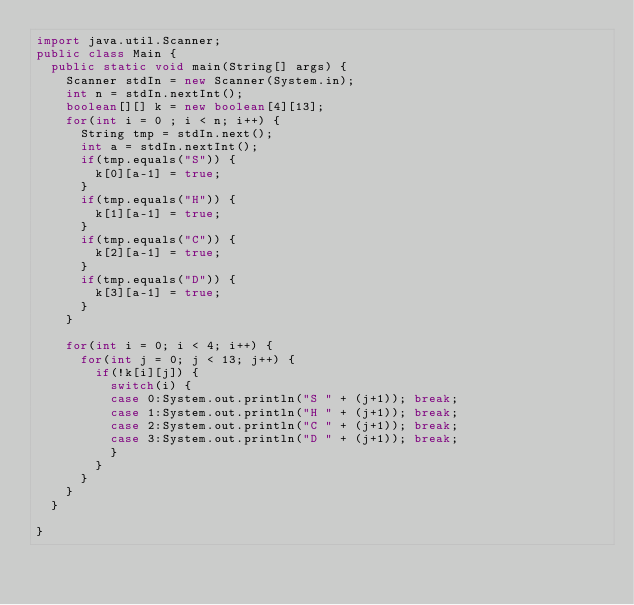Convert code to text. <code><loc_0><loc_0><loc_500><loc_500><_Java_>import java.util.Scanner;
public class Main {
	public static void main(String[] args) {
		Scanner stdIn = new Scanner(System.in);
		int n = stdIn.nextInt();
		boolean[][] k = new boolean[4][13];
		for(int i = 0 ; i < n; i++) {
			String tmp = stdIn.next();
			int a = stdIn.nextInt();
			if(tmp.equals("S")) {
				k[0][a-1] = true;
			}
			if(tmp.equals("H")) {
				k[1][a-1] = true;
			}
			if(tmp.equals("C")) {
				k[2][a-1] = true;
			}
			if(tmp.equals("D")) {
				k[3][a-1] = true;
			}
		}
		
		for(int i = 0; i < 4; i++) {
			for(int j = 0; j < 13; j++) {
				if(!k[i][j]) {
					switch(i) {
					case 0:System.out.println("S " + (j+1)); break;
					case 1:System.out.println("H " + (j+1)); break;
					case 2:System.out.println("C " + (j+1)); break;
					case 3:System.out.println("D " + (j+1)); break;
					}
				}
			}
		}
	}
	
}</code> 